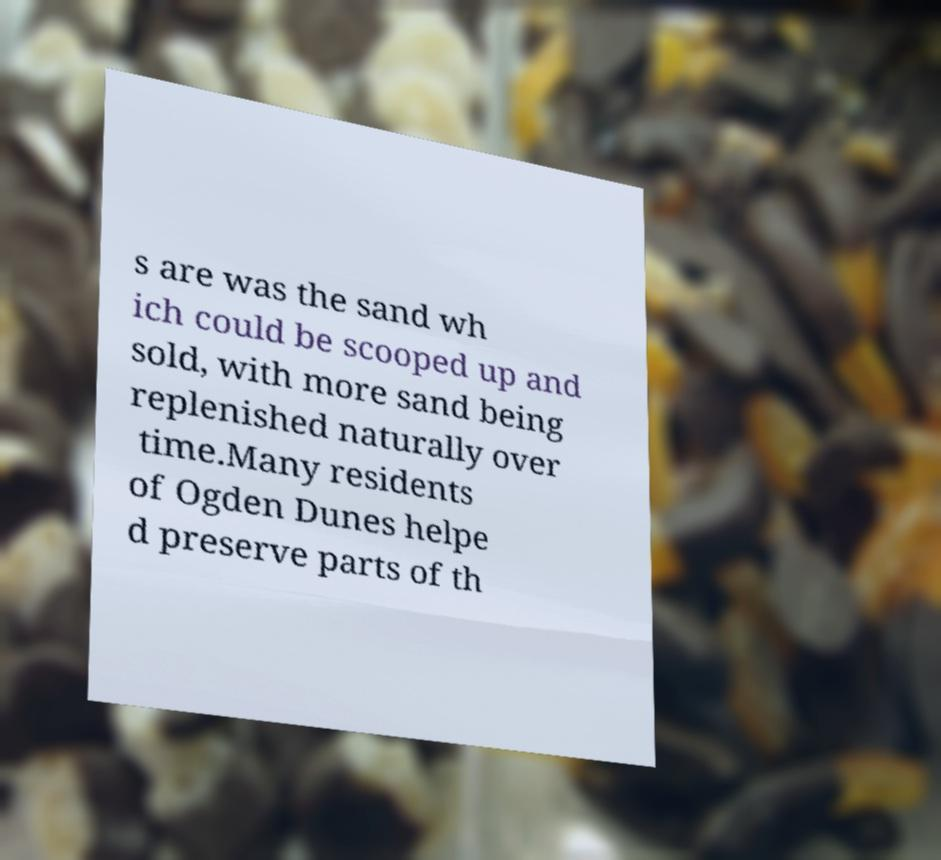There's text embedded in this image that I need extracted. Can you transcribe it verbatim? s are was the sand wh ich could be scooped up and sold, with more sand being replenished naturally over time.Many residents of Ogden Dunes helpe d preserve parts of th 